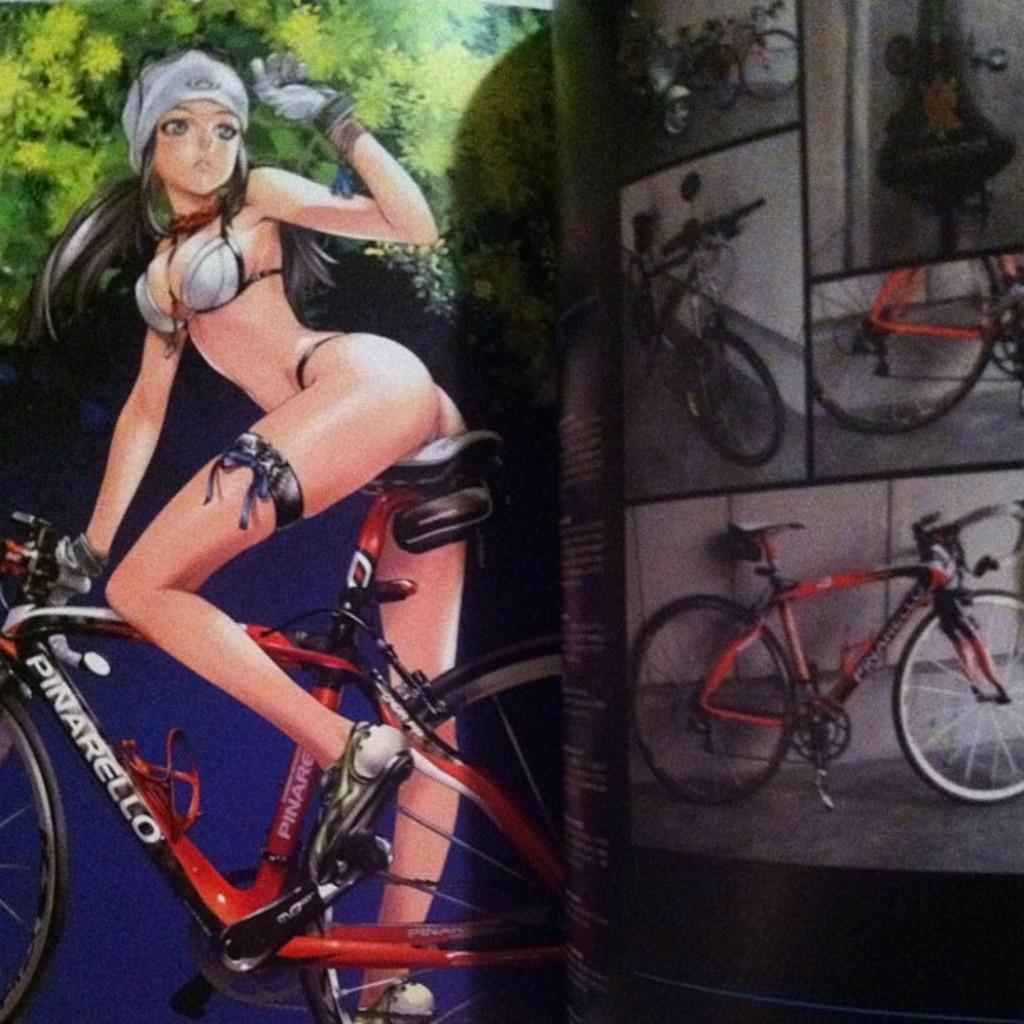What type of media is the image? The image is an animation. Can you describe the character in the image? There is a beautiful character in the image. What is the character doing in the image? The character is riding a cycle. How many beds are visible in the image? There are no beds present in the image, as it is an animation featuring a character riding a cycle. What sense does the character in the image possess? The provided facts do not mention any specific senses possessed by the character, so it cannot be determined from the image. 